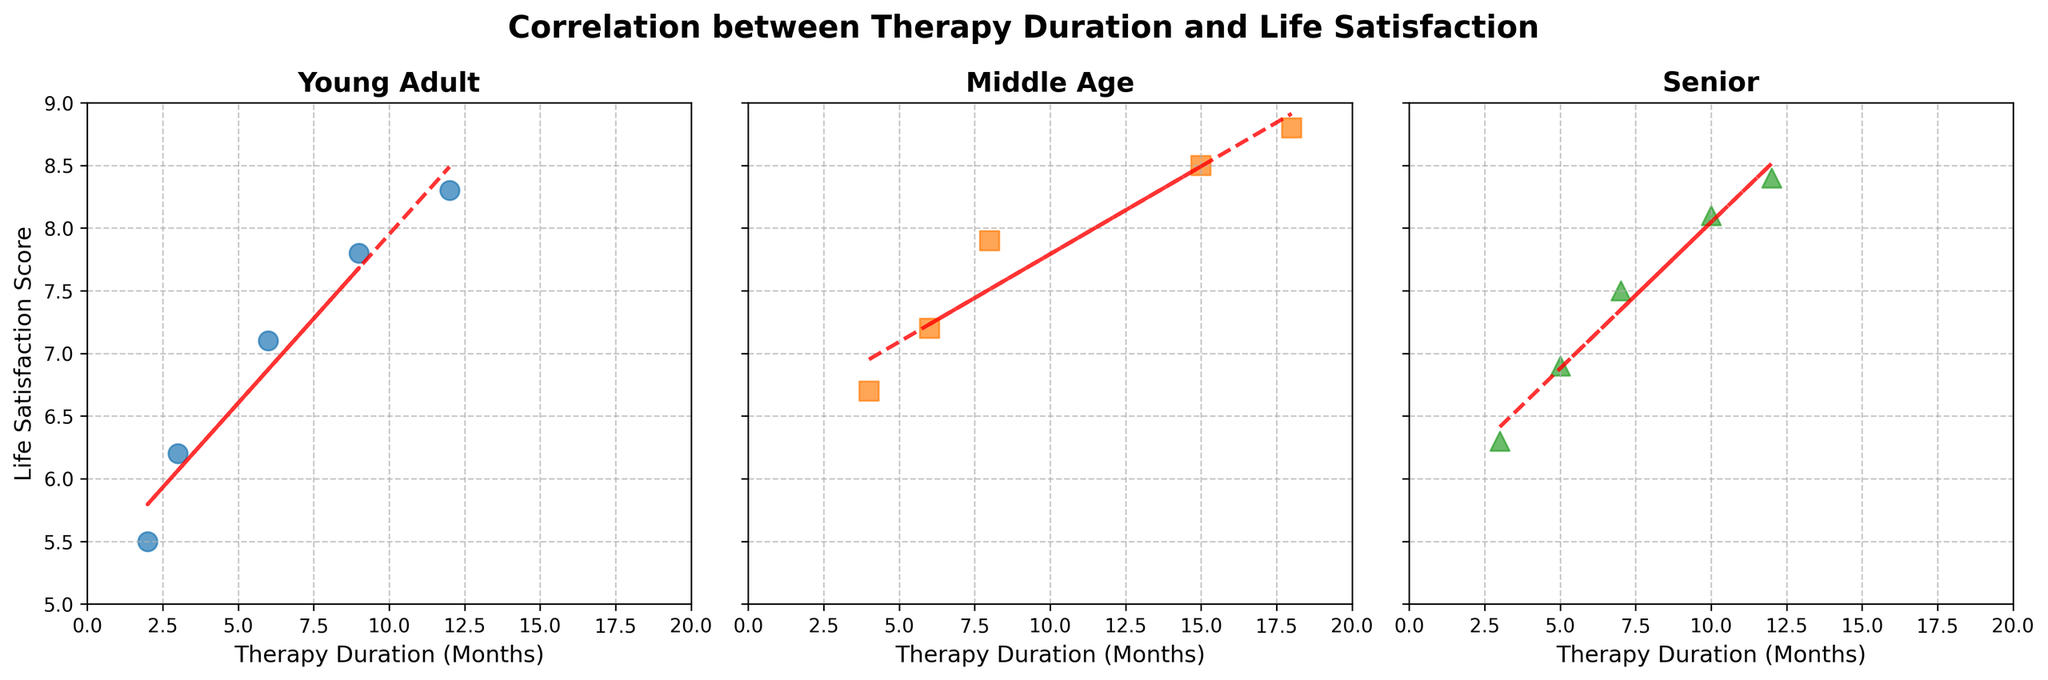What is the title of the plot? The title is usually located at the top center of the figure and provides a brief description of the data. Here, the title reads "Correlation between Therapy Duration and Life Satisfaction."
Answer: Correlation between Therapy Duration and Life Satisfaction How many age groups are compared in the figure? By examining the subplots, it is evident that there are three distinct sections labeled "Young Adult," "Middle Age," and "Senior."
Answer: Three Which age group has the highest life satisfaction score? In the subplots, the highest life satisfaction score appears near the top of the y-axis. For "Young Adult," the score is around 8.3; for "Middle Age," it's about 8.8; and for "Senior," it's also near 8.8. Comparing them, "Middle Age" and "Senior" have the highest score of approximately 8.8.
Answer: Middle Age and Senior What is the overall trend for life satisfaction scores as therapy duration increases for the Young Adult group? Observing the trend line in the Young Adult subplot, it appears to be upward-sloping, indicating that life satisfaction scores generally increase as therapy duration lengthens.
Answer: Increase Which group shows the most variation in life satisfaction scores? The group with the broadest range of scores on the y-axis (5 to 9 scale) demonstrates the most variation. The "Senior" group has data points ranging from approximately 6.3 to 8.4.
Answer: Senior What is the color used to represent the 'Middle Age' group? The color associated with the 'Middle Age' subplot is orange, as seen in its scatter points and trend line.
Answer: Orange Which age group has the longest therapy duration? By looking at the x-axis labeled 'Therapy Duration (Months)', the 'Middle Age' group has data points extending up to 18 months, the longest compared to other groups.
Answer: Middle Age What is the average life satisfaction score for therapy durations of 6 months in each age group? For 'Young Adult', the score for 6 months is 7.1; for 'Middle Age', the score is 7.2; and for 'Senior', there's no exact 6-month data point. (No calculation needed here, just reading values.)
Answer: 7.1 (Young Adult), 7.2 (Middle Age) Does any group show a negative trend in their life satisfaction scores over the therapy duration? Examining the trend lines of all three subplots, each trend line is positively sloped, indicating that none of the groups show a negative trend.
Answer: No What is the therapy duration for which both 'Young Adult' and 'Middle Age' groups have close life satisfaction scores, and what are those scores? From the subplots, when therapy duration is around 6 months, 'Young Adult' has a score of 7.1, and 'Middle Age' has a score of 7.2. These scores are close to each other.
Answer: 6 months, 7.1 (Young Adult), 7.2 (Middle Age) 